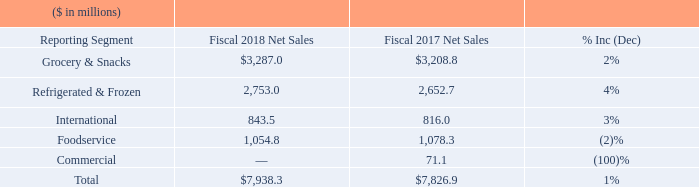Fiscal 2018 compared to Fiscal 2017
Net Sales
Overall, our net sales were $7.94 billion in fiscal 2018, an increase of 1% compared to fiscal 2017.
Grocery & Snacks net sales for fiscal 2018 were $3.29 billion, an increase of $78.2 million, or 2%, compared to fiscal 2017. Results reflected a decrease in volumes of approximately 2% in fiscal 2018 compared to the prior-year period, excluding the impact of acquisitions. The decrease in sales volumes reflected a reduction in promotional intensity, planned discontinuation of certain lower-performing products, retailer inventory reductions, which were higher than anticipated, and deliberate actions to optimize distribution on certain lower-margin products, consistent with the Company's value over volume strategy. Price/ mix was flat compared to the prior-year period as favorable mix improvements from recent innovation and higher net pricing nearly offset continued investments in retailer marketing to drive brand saliency, enhanced distribution, and consumer trial. The acquisition of Angie's Artisan Treats, LLC contributed $68.1 million to Grocery & Snacks net sales during fiscal 2018. The Frontera acquisition contributed $8.6 million and the Thanasi acquisition contributed $66.5 million to Grocery & Snacks net sales during fiscal 2018 through the one-year anniversaries of the acquisitions. The Frontera and Thanasi acquisitions occurred in September 2016 and April 2017, respectively.
Refrigerated & Frozen net sales for fiscal 2018 were $2.75 billion, an increase of $100.3 million, or 4%, compared to fiscal 2017. Results for fiscal 2018 reflected a 3% increase in volume compared to fiscal 2017, excluding the impact of 31 acquisitions. The increase in sales volumes was a result of brand renovation and innovation launches. Price/mix was flat compared to fiscal 2017, as favorability in both net pricing and mix offset continued investment in retailer marketing to drive brand saliency, enhanced distribution, and consumer trial. The acquisition of the Sandwich Bros. of Wisconsin® business contributed $21.3 million to Refrigerated & Frozen's net sales during fiscal 2018. The Frontera acquisition, which occurred in September 2016, and subsequent innovation in the Frontera® brand contributed $4.4 million during fiscal 2018 through the one-year anniversary of the acquisition.
International net sales for fiscal 2018 were $843.5 million, an increase of $27.5 million, or 3%, compared to fiscal 2017. Results for fiscal 2018 reflected a 3% decrease in volume, a 3% increase due to foreign exchange rates, and a 3% increase in price/mix, in each case compared to fiscal 2017. The volume decrease for fiscal 2018 was driven by strategic decisions to eliminate lower margin products and to reduce promotional intensity. The increase in price/mix compared to the prior-year period was driven by improvements in pricing and trade productivity.
Foodservice net sales for fiscal 2018 were $1.05 billion, a decrease of $23.5 million, or 2%, compared to fiscal 2017. Results for fiscal 2018 reflected an 11% decrease in volume, partially offset by a 9% increase in price/mix compared to fiscal 2017. The decrease in volumes compared to the prior year primarily reflected the impact of exiting a non-core business, the planned discontinuation of certain lower-performing businesses, and softness in certain categories. The increase in price/mix for fiscal 2018 reflected favorable product and customer mix, the impact of inflation-driven increases in pricing, and the execution of the segment's value over volume strategy.
In the first quarter of fiscal 2017, we divested our Spicetec and JM Swank businesses. These businesses comprise the entire Commercial segment following the presentation of Lamb Weston as discontinued operations. Accordingly, there were no net sales in the Commercial segment after the first quarter of fiscal 2017. These businesses had net sales of $71.1 million in fiscal 2017 prior to the completion of the divestitures.
What was the net sales  of Foodservice in the fiscal year 2018 and 2017, respectively?
Answer scale should be: million. 1,054.8, 1,078.3. What drove the volume decrease in the International segment for the fiscal year 2018?  Strategic decisions to eliminate lower margin products and to reduce promotional intensity. When did the Frontera acquisition occur? September 2016. What is the proportion (in percentage) of sales from innovation in the Frontera brand over Refrigerated & Frozen’s net sales in the fiscal year 2018?
Answer scale should be: percent. 4.4/2,753.0 
Answer: 0.16. What is the proportion (in percentage) of sales from the Frontera acquisition and Thanasi acquisition over Grocery & Snacks’ net sales in the fiscal year 2018?
Answer scale should be: percent. (8.6+66.5)/$3,287.0 
Answer: 2.28. What is the percentage change in total net sales of International and Refrigerated & Frozen from the fiscal year 2017 to 2018?
Answer scale should be: percent. ((843.5+2,753.0)-(816.0+2,652.7))/(816.0+2,652.7) 
Answer: 3.68. 